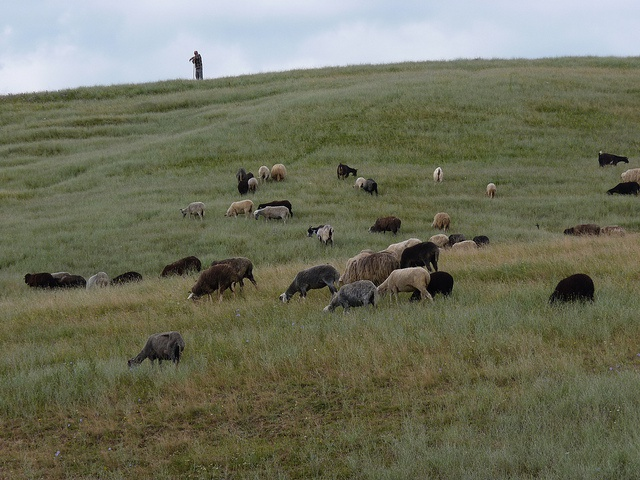Describe the objects in this image and their specific colors. I can see sheep in lavender, black, gray, and darkgreen tones, sheep in lavender, gray, and black tones, sheep in lavender, black, gray, and darkgreen tones, sheep in lavender, black, and gray tones, and sheep in lavender, gray, and black tones in this image. 